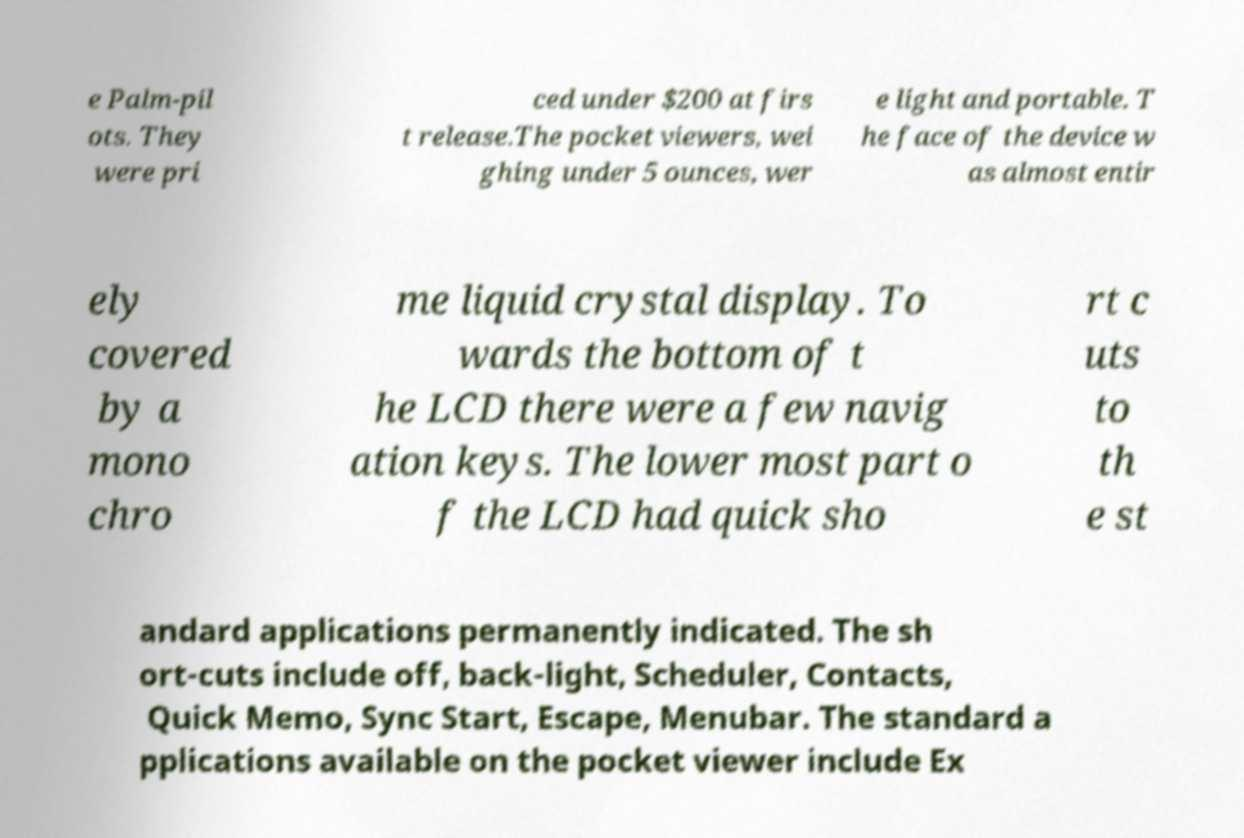Could you extract and type out the text from this image? e Palm-pil ots. They were pri ced under $200 at firs t release.The pocket viewers, wei ghing under 5 ounces, wer e light and portable. T he face of the device w as almost entir ely covered by a mono chro me liquid crystal display. To wards the bottom of t he LCD there were a few navig ation keys. The lower most part o f the LCD had quick sho rt c uts to th e st andard applications permanently indicated. The sh ort-cuts include off, back-light, Scheduler, Contacts, Quick Memo, Sync Start, Escape, Menubar. The standard a pplications available on the pocket viewer include Ex 